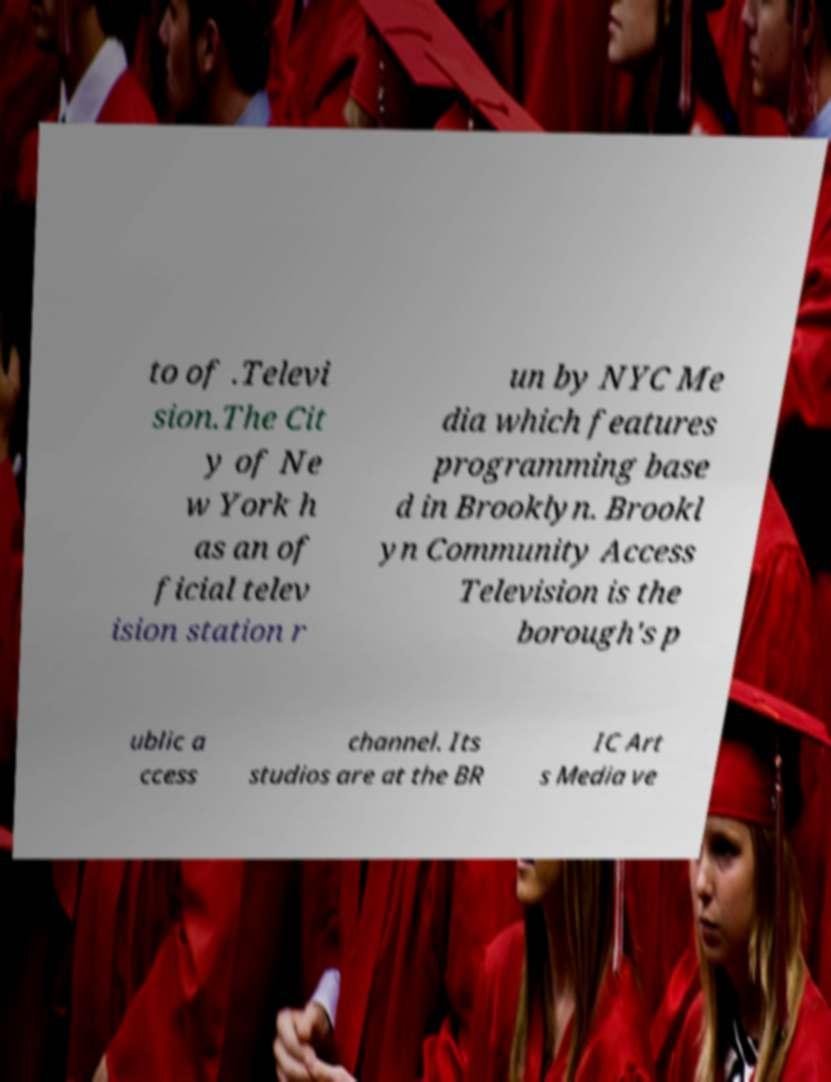There's text embedded in this image that I need extracted. Can you transcribe it verbatim? to of .Televi sion.The Cit y of Ne w York h as an of ficial telev ision station r un by NYC Me dia which features programming base d in Brooklyn. Brookl yn Community Access Television is the borough's p ublic a ccess channel. Its studios are at the BR IC Art s Media ve 